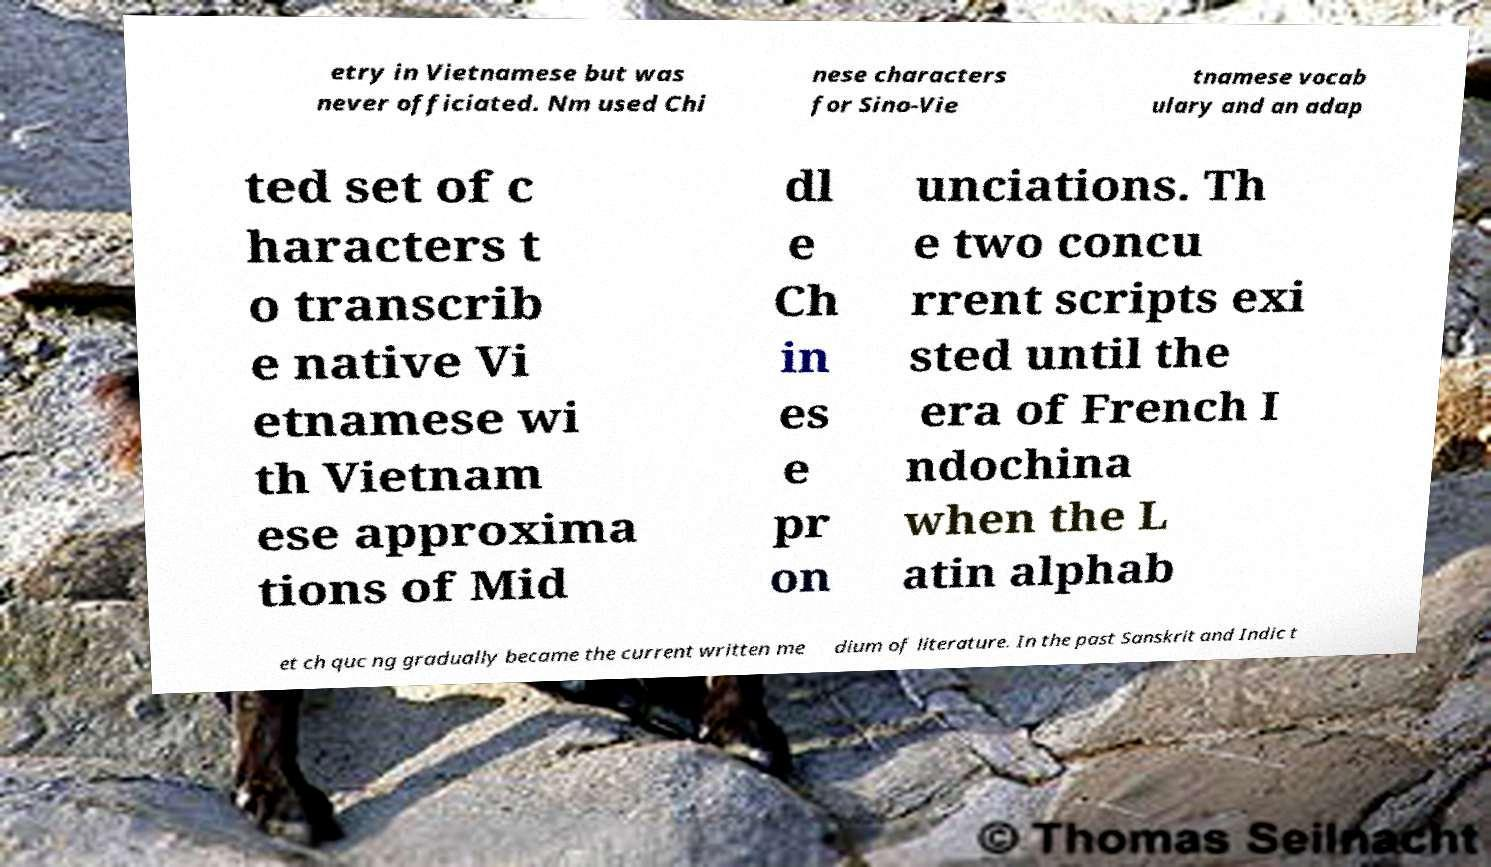For documentation purposes, I need the text within this image transcribed. Could you provide that? etry in Vietnamese but was never officiated. Nm used Chi nese characters for Sino-Vie tnamese vocab ulary and an adap ted set of c haracters t o transcrib e native Vi etnamese wi th Vietnam ese approxima tions of Mid dl e Ch in es e pr on unciations. Th e two concu rrent scripts exi sted until the era of French I ndochina when the L atin alphab et ch quc ng gradually became the current written me dium of literature. In the past Sanskrit and Indic t 